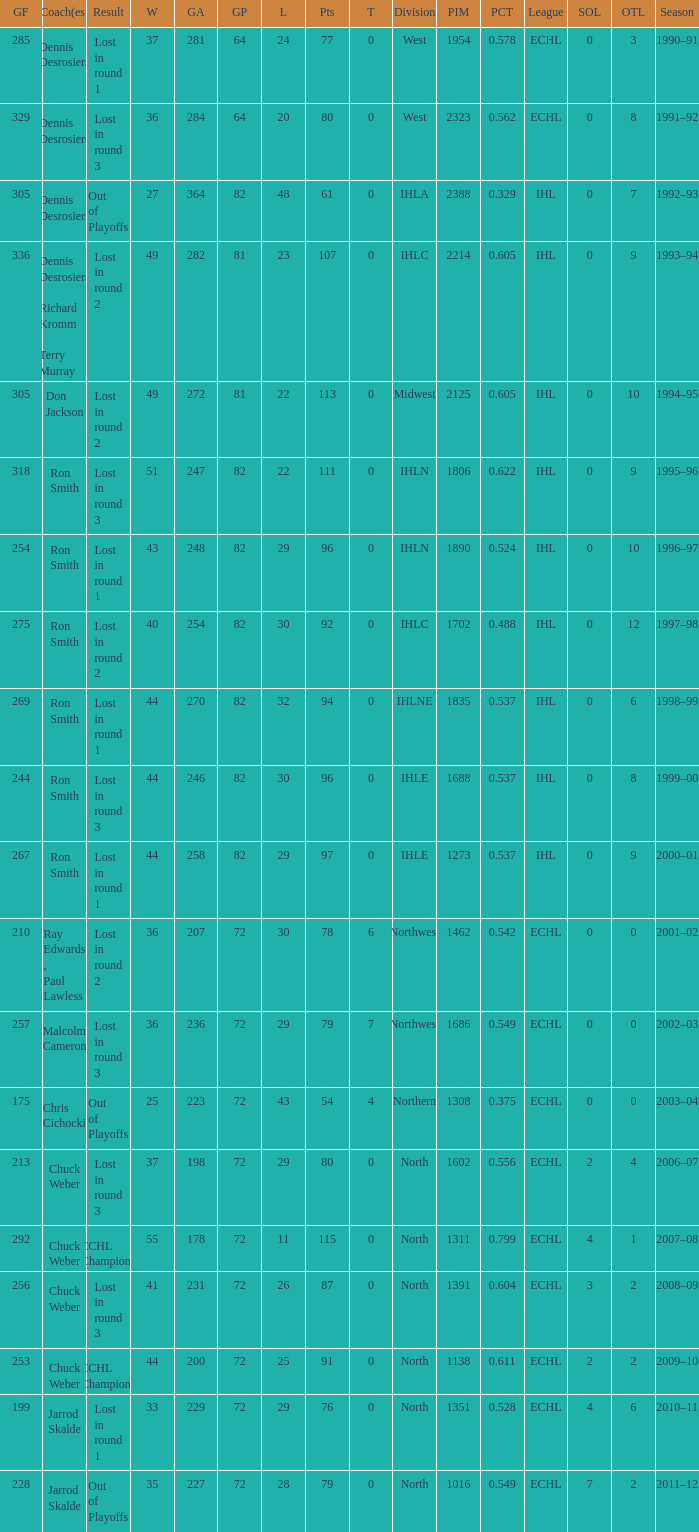Can you give me this table as a dict? {'header': ['GF', 'Coach(es)', 'Result', 'W', 'GA', 'GP', 'L', 'Pts', 'T', 'Division', 'PIM', 'PCT', 'League', 'SOL', 'OTL', 'Season'], 'rows': [['285', 'Dennis Desrosiers', 'Lost in round 1', '37', '281', '64', '24', '77', '0', 'West', '1954', '0.578', 'ECHL', '0', '3', '1990–91'], ['329', 'Dennis Desrosiers', 'Lost in round 3', '36', '284', '64', '20', '80', '0', 'West', '2323', '0.562', 'ECHL', '0', '8', '1991–92'], ['305', 'Dennis Desrosiers', 'Out of Playoffs', '27', '364', '82', '48', '61', '0', 'IHLA', '2388', '0.329', 'IHL', '0', '7', '1992–93'], ['336', 'Dennis Desrosiers , Richard Kromm , Terry Murray', 'Lost in round 2', '49', '282', '81', '23', '107', '0', 'IHLC', '2214', '0.605', 'IHL', '0', '9', '1993–94'], ['305', 'Don Jackson', 'Lost in round 2', '49', '272', '81', '22', '113', '0', 'Midwest', '2125', '0.605', 'IHL', '0', '10', '1994–95'], ['318', 'Ron Smith', 'Lost in round 3', '51', '247', '82', '22', '111', '0', 'IHLN', '1806', '0.622', 'IHL', '0', '9', '1995–96'], ['254', 'Ron Smith', 'Lost in round 1', '43', '248', '82', '29', '96', '0', 'IHLN', '1890', '0.524', 'IHL', '0', '10', '1996–97'], ['275', 'Ron Smith', 'Lost in round 2', '40', '254', '82', '30', '92', '0', 'IHLC', '1702', '0.488', 'IHL', '0', '12', '1997–98'], ['269', 'Ron Smith', 'Lost in round 1', '44', '270', '82', '32', '94', '0', 'IHLNE', '1835', '0.537', 'IHL', '0', '6', '1998–99'], ['244', 'Ron Smith', 'Lost in round 3', '44', '246', '82', '30', '96', '0', 'IHLE', '1688', '0.537', 'IHL', '0', '8', '1999–00'], ['267', 'Ron Smith', 'Lost in round 1', '44', '258', '82', '29', '97', '0', 'IHLE', '1273', '0.537', 'IHL', '0', '9', '2000–01'], ['210', 'Ray Edwards , Paul Lawless', 'Lost in round 2', '36', '207', '72', '30', '78', '6', 'Northwest', '1462', '0.542', 'ECHL', '0', '0', '2001–02'], ['257', 'Malcolm Cameron', 'Lost in round 3', '36', '236', '72', '29', '79', '7', 'Northwest', '1686', '0.549', 'ECHL', '0', '0', '2002–03'], ['175', 'Chris Cichocki', 'Out of Playoffs', '25', '223', '72', '43', '54', '4', 'Northern', '1308', '0.375', 'ECHL', '0', '0', '2003–04'], ['213', 'Chuck Weber', 'Lost in round 3', '37', '198', '72', '29', '80', '0', 'North', '1602', '0.556', 'ECHL', '2', '4', '2006–07'], ['292', 'Chuck Weber', 'ECHL Champions', '55', '178', '72', '11', '115', '0', 'North', '1311', '0.799', 'ECHL', '4', '1', '2007–08'], ['256', 'Chuck Weber', 'Lost in round 3', '41', '231', '72', '26', '87', '0', 'North', '1391', '0.604', 'ECHL', '3', '2', '2008–09'], ['253', 'Chuck Weber', 'ECHL Champions', '44', '200', '72', '25', '91', '0', 'North', '1138', '0.611', 'ECHL', '2', '2', '2009–10'], ['199', 'Jarrod Skalde', 'Lost in round 1', '33', '229', '72', '29', '76', '0', 'North', '1351', '0.528', 'ECHL', '4', '6', '2010–11'], ['228', 'Jarrod Skalde', 'Out of Playoffs', '35', '227', '72', '28', '79', '0', 'North', '1016', '0.549', 'ECHL', '7', '2', '2011–12']]} What was the minimum L if the GA is 272? 22.0. 